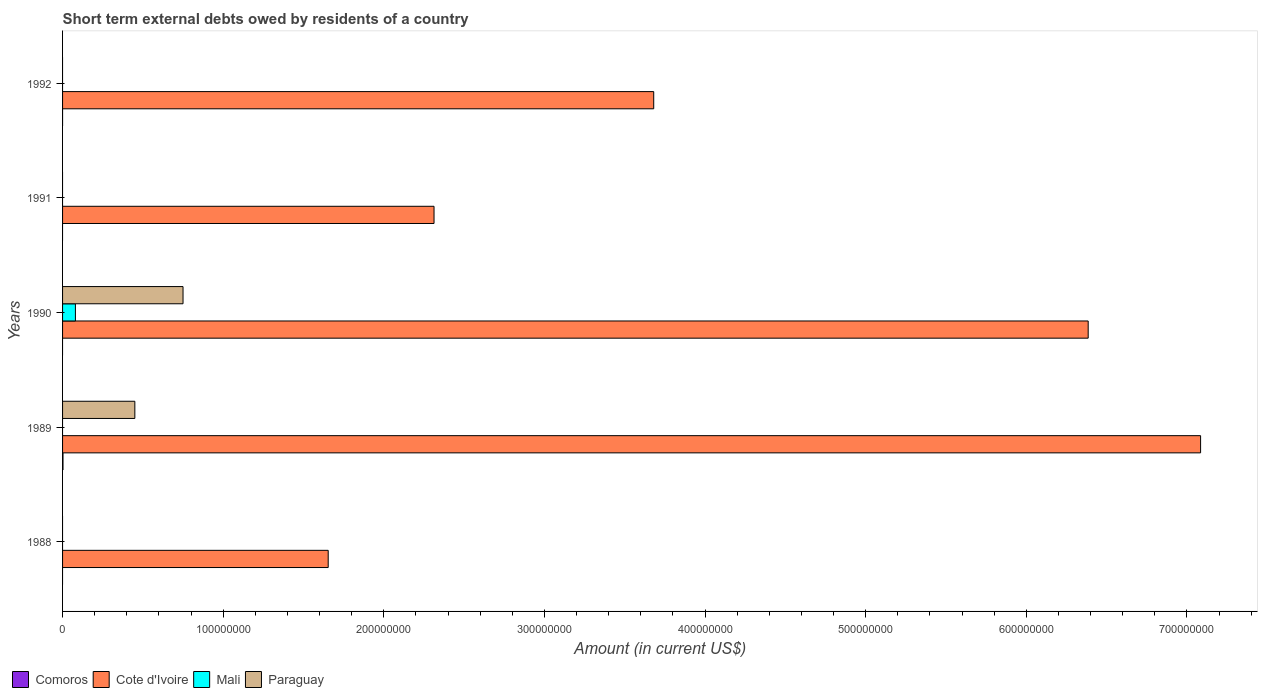How many bars are there on the 2nd tick from the top?
Offer a very short reply. 1. Across all years, what is the maximum amount of short-term external debts owed by residents in Cote d'Ivoire?
Make the answer very short. 7.09e+08. Across all years, what is the minimum amount of short-term external debts owed by residents in Comoros?
Provide a succinct answer. 0. In which year was the amount of short-term external debts owed by residents in Cote d'Ivoire maximum?
Your answer should be compact. 1989. What is the total amount of short-term external debts owed by residents in Paraguay in the graph?
Make the answer very short. 1.20e+08. What is the difference between the amount of short-term external debts owed by residents in Cote d'Ivoire in 1988 and that in 1989?
Ensure brevity in your answer.  -5.43e+08. What is the difference between the amount of short-term external debts owed by residents in Paraguay in 1990 and the amount of short-term external debts owed by residents in Mali in 1989?
Offer a very short reply. 7.50e+07. What is the average amount of short-term external debts owed by residents in Mali per year?
Make the answer very short. 1.60e+06. What is the ratio of the amount of short-term external debts owed by residents in Cote d'Ivoire in 1988 to that in 1991?
Your answer should be very brief. 0.72. Is the amount of short-term external debts owed by residents in Cote d'Ivoire in 1988 less than that in 1991?
Give a very brief answer. Yes. What is the difference between the highest and the second highest amount of short-term external debts owed by residents in Cote d'Ivoire?
Make the answer very short. 7.00e+07. What is the difference between the highest and the lowest amount of short-term external debts owed by residents in Cote d'Ivoire?
Make the answer very short. 5.43e+08. In how many years, is the amount of short-term external debts owed by residents in Paraguay greater than the average amount of short-term external debts owed by residents in Paraguay taken over all years?
Your answer should be compact. 2. Is it the case that in every year, the sum of the amount of short-term external debts owed by residents in Mali and amount of short-term external debts owed by residents in Cote d'Ivoire is greater than the sum of amount of short-term external debts owed by residents in Comoros and amount of short-term external debts owed by residents in Paraguay?
Offer a very short reply. Yes. How many bars are there?
Provide a succinct answer. 9. Are all the bars in the graph horizontal?
Your answer should be very brief. Yes. How many years are there in the graph?
Ensure brevity in your answer.  5. What is the difference between two consecutive major ticks on the X-axis?
Your response must be concise. 1.00e+08. Are the values on the major ticks of X-axis written in scientific E-notation?
Offer a very short reply. No. Where does the legend appear in the graph?
Offer a terse response. Bottom left. How many legend labels are there?
Your answer should be compact. 4. How are the legend labels stacked?
Provide a succinct answer. Horizontal. What is the title of the graph?
Provide a succinct answer. Short term external debts owed by residents of a country. What is the label or title of the X-axis?
Your response must be concise. Amount (in current US$). What is the Amount (in current US$) in Comoros in 1988?
Offer a very short reply. 0. What is the Amount (in current US$) in Cote d'Ivoire in 1988?
Your answer should be compact. 1.65e+08. What is the Amount (in current US$) of Mali in 1988?
Your answer should be compact. 0. What is the Amount (in current US$) in Comoros in 1989?
Provide a short and direct response. 2.70e+05. What is the Amount (in current US$) of Cote d'Ivoire in 1989?
Offer a terse response. 7.09e+08. What is the Amount (in current US$) in Paraguay in 1989?
Give a very brief answer. 4.50e+07. What is the Amount (in current US$) in Comoros in 1990?
Keep it short and to the point. 0. What is the Amount (in current US$) in Cote d'Ivoire in 1990?
Offer a terse response. 6.39e+08. What is the Amount (in current US$) in Mali in 1990?
Offer a very short reply. 8.00e+06. What is the Amount (in current US$) of Paraguay in 1990?
Provide a short and direct response. 7.50e+07. What is the Amount (in current US$) in Comoros in 1991?
Ensure brevity in your answer.  0. What is the Amount (in current US$) in Cote d'Ivoire in 1991?
Your answer should be very brief. 2.31e+08. What is the Amount (in current US$) in Mali in 1991?
Keep it short and to the point. 0. What is the Amount (in current US$) of Cote d'Ivoire in 1992?
Keep it short and to the point. 3.68e+08. What is the Amount (in current US$) in Mali in 1992?
Provide a short and direct response. 0. What is the Amount (in current US$) of Paraguay in 1992?
Provide a short and direct response. 0. Across all years, what is the maximum Amount (in current US$) in Comoros?
Make the answer very short. 2.70e+05. Across all years, what is the maximum Amount (in current US$) in Cote d'Ivoire?
Your answer should be very brief. 7.09e+08. Across all years, what is the maximum Amount (in current US$) of Mali?
Provide a short and direct response. 8.00e+06. Across all years, what is the maximum Amount (in current US$) in Paraguay?
Keep it short and to the point. 7.50e+07. Across all years, what is the minimum Amount (in current US$) of Comoros?
Offer a terse response. 0. Across all years, what is the minimum Amount (in current US$) of Cote d'Ivoire?
Provide a succinct answer. 1.65e+08. Across all years, what is the minimum Amount (in current US$) of Mali?
Offer a terse response. 0. What is the total Amount (in current US$) of Cote d'Ivoire in the graph?
Give a very brief answer. 2.11e+09. What is the total Amount (in current US$) of Paraguay in the graph?
Give a very brief answer. 1.20e+08. What is the difference between the Amount (in current US$) in Cote d'Ivoire in 1988 and that in 1989?
Provide a succinct answer. -5.43e+08. What is the difference between the Amount (in current US$) of Cote d'Ivoire in 1988 and that in 1990?
Your answer should be very brief. -4.73e+08. What is the difference between the Amount (in current US$) of Cote d'Ivoire in 1988 and that in 1991?
Keep it short and to the point. -6.59e+07. What is the difference between the Amount (in current US$) in Cote d'Ivoire in 1988 and that in 1992?
Provide a short and direct response. -2.03e+08. What is the difference between the Amount (in current US$) in Cote d'Ivoire in 1989 and that in 1990?
Keep it short and to the point. 7.00e+07. What is the difference between the Amount (in current US$) in Paraguay in 1989 and that in 1990?
Your answer should be very brief. -3.00e+07. What is the difference between the Amount (in current US$) of Cote d'Ivoire in 1989 and that in 1991?
Your answer should be very brief. 4.77e+08. What is the difference between the Amount (in current US$) in Cote d'Ivoire in 1989 and that in 1992?
Keep it short and to the point. 3.40e+08. What is the difference between the Amount (in current US$) of Cote d'Ivoire in 1990 and that in 1991?
Your answer should be compact. 4.07e+08. What is the difference between the Amount (in current US$) in Cote d'Ivoire in 1990 and that in 1992?
Make the answer very short. 2.70e+08. What is the difference between the Amount (in current US$) in Cote d'Ivoire in 1991 and that in 1992?
Give a very brief answer. -1.37e+08. What is the difference between the Amount (in current US$) of Cote d'Ivoire in 1988 and the Amount (in current US$) of Paraguay in 1989?
Make the answer very short. 1.20e+08. What is the difference between the Amount (in current US$) in Cote d'Ivoire in 1988 and the Amount (in current US$) in Mali in 1990?
Make the answer very short. 1.57e+08. What is the difference between the Amount (in current US$) of Cote d'Ivoire in 1988 and the Amount (in current US$) of Paraguay in 1990?
Provide a short and direct response. 9.04e+07. What is the difference between the Amount (in current US$) of Comoros in 1989 and the Amount (in current US$) of Cote d'Ivoire in 1990?
Provide a succinct answer. -6.38e+08. What is the difference between the Amount (in current US$) of Comoros in 1989 and the Amount (in current US$) of Mali in 1990?
Offer a very short reply. -7.73e+06. What is the difference between the Amount (in current US$) in Comoros in 1989 and the Amount (in current US$) in Paraguay in 1990?
Provide a succinct answer. -7.47e+07. What is the difference between the Amount (in current US$) in Cote d'Ivoire in 1989 and the Amount (in current US$) in Mali in 1990?
Make the answer very short. 7.01e+08. What is the difference between the Amount (in current US$) in Cote d'Ivoire in 1989 and the Amount (in current US$) in Paraguay in 1990?
Give a very brief answer. 6.34e+08. What is the difference between the Amount (in current US$) in Comoros in 1989 and the Amount (in current US$) in Cote d'Ivoire in 1991?
Ensure brevity in your answer.  -2.31e+08. What is the difference between the Amount (in current US$) in Comoros in 1989 and the Amount (in current US$) in Cote d'Ivoire in 1992?
Give a very brief answer. -3.68e+08. What is the average Amount (in current US$) of Comoros per year?
Ensure brevity in your answer.  5.40e+04. What is the average Amount (in current US$) in Cote d'Ivoire per year?
Your answer should be very brief. 4.22e+08. What is the average Amount (in current US$) of Mali per year?
Your response must be concise. 1.60e+06. What is the average Amount (in current US$) in Paraguay per year?
Make the answer very short. 2.40e+07. In the year 1989, what is the difference between the Amount (in current US$) of Comoros and Amount (in current US$) of Cote d'Ivoire?
Make the answer very short. -7.08e+08. In the year 1989, what is the difference between the Amount (in current US$) of Comoros and Amount (in current US$) of Paraguay?
Provide a short and direct response. -4.47e+07. In the year 1989, what is the difference between the Amount (in current US$) in Cote d'Ivoire and Amount (in current US$) in Paraguay?
Provide a succinct answer. 6.64e+08. In the year 1990, what is the difference between the Amount (in current US$) in Cote d'Ivoire and Amount (in current US$) in Mali?
Keep it short and to the point. 6.31e+08. In the year 1990, what is the difference between the Amount (in current US$) of Cote d'Ivoire and Amount (in current US$) of Paraguay?
Provide a succinct answer. 5.64e+08. In the year 1990, what is the difference between the Amount (in current US$) in Mali and Amount (in current US$) in Paraguay?
Give a very brief answer. -6.70e+07. What is the ratio of the Amount (in current US$) in Cote d'Ivoire in 1988 to that in 1989?
Your response must be concise. 0.23. What is the ratio of the Amount (in current US$) in Cote d'Ivoire in 1988 to that in 1990?
Offer a very short reply. 0.26. What is the ratio of the Amount (in current US$) in Cote d'Ivoire in 1988 to that in 1991?
Give a very brief answer. 0.72. What is the ratio of the Amount (in current US$) of Cote d'Ivoire in 1988 to that in 1992?
Make the answer very short. 0.45. What is the ratio of the Amount (in current US$) in Cote d'Ivoire in 1989 to that in 1990?
Offer a terse response. 1.11. What is the ratio of the Amount (in current US$) in Cote d'Ivoire in 1989 to that in 1991?
Your response must be concise. 3.06. What is the ratio of the Amount (in current US$) of Cote d'Ivoire in 1989 to that in 1992?
Your answer should be compact. 1.93. What is the ratio of the Amount (in current US$) in Cote d'Ivoire in 1990 to that in 1991?
Make the answer very short. 2.76. What is the ratio of the Amount (in current US$) in Cote d'Ivoire in 1990 to that in 1992?
Offer a very short reply. 1.73. What is the ratio of the Amount (in current US$) of Cote d'Ivoire in 1991 to that in 1992?
Offer a very short reply. 0.63. What is the difference between the highest and the second highest Amount (in current US$) in Cote d'Ivoire?
Keep it short and to the point. 7.00e+07. What is the difference between the highest and the lowest Amount (in current US$) of Comoros?
Offer a very short reply. 2.70e+05. What is the difference between the highest and the lowest Amount (in current US$) in Cote d'Ivoire?
Your answer should be very brief. 5.43e+08. What is the difference between the highest and the lowest Amount (in current US$) in Mali?
Your answer should be compact. 8.00e+06. What is the difference between the highest and the lowest Amount (in current US$) of Paraguay?
Offer a terse response. 7.50e+07. 